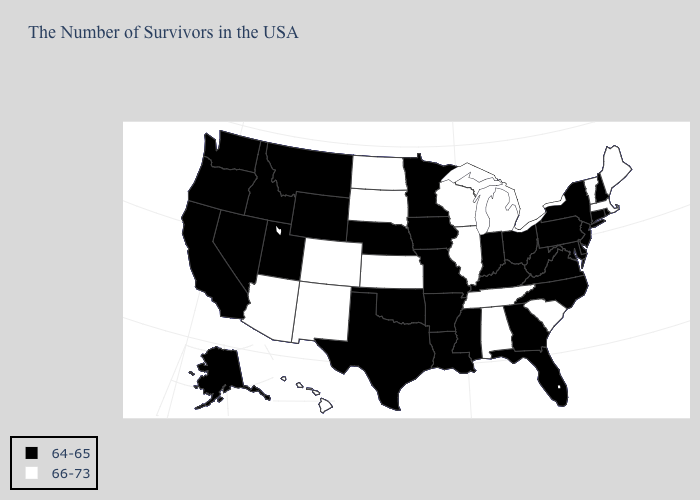Which states hav the highest value in the South?
Answer briefly. South Carolina, Alabama, Tennessee. Does the first symbol in the legend represent the smallest category?
Quick response, please. Yes. What is the value of Kansas?
Keep it brief. 66-73. Does California have a lower value than Connecticut?
Write a very short answer. No. Does Idaho have a higher value than Iowa?
Write a very short answer. No. Name the states that have a value in the range 66-73?
Answer briefly. Maine, Massachusetts, Vermont, South Carolina, Michigan, Alabama, Tennessee, Wisconsin, Illinois, Kansas, South Dakota, North Dakota, Colorado, New Mexico, Arizona, Hawaii. Name the states that have a value in the range 66-73?
Answer briefly. Maine, Massachusetts, Vermont, South Carolina, Michigan, Alabama, Tennessee, Wisconsin, Illinois, Kansas, South Dakota, North Dakota, Colorado, New Mexico, Arizona, Hawaii. Name the states that have a value in the range 64-65?
Answer briefly. Rhode Island, New Hampshire, Connecticut, New York, New Jersey, Delaware, Maryland, Pennsylvania, Virginia, North Carolina, West Virginia, Ohio, Florida, Georgia, Kentucky, Indiana, Mississippi, Louisiana, Missouri, Arkansas, Minnesota, Iowa, Nebraska, Oklahoma, Texas, Wyoming, Utah, Montana, Idaho, Nevada, California, Washington, Oregon, Alaska. Which states have the lowest value in the USA?
Write a very short answer. Rhode Island, New Hampshire, Connecticut, New York, New Jersey, Delaware, Maryland, Pennsylvania, Virginia, North Carolina, West Virginia, Ohio, Florida, Georgia, Kentucky, Indiana, Mississippi, Louisiana, Missouri, Arkansas, Minnesota, Iowa, Nebraska, Oklahoma, Texas, Wyoming, Utah, Montana, Idaho, Nevada, California, Washington, Oregon, Alaska. Does Vermont have the highest value in the Northeast?
Keep it brief. Yes. What is the value of West Virginia?
Be succinct. 64-65. Among the states that border Oklahoma , does Colorado have the lowest value?
Short answer required. No. Name the states that have a value in the range 66-73?
Concise answer only. Maine, Massachusetts, Vermont, South Carolina, Michigan, Alabama, Tennessee, Wisconsin, Illinois, Kansas, South Dakota, North Dakota, Colorado, New Mexico, Arizona, Hawaii. Name the states that have a value in the range 64-65?
Give a very brief answer. Rhode Island, New Hampshire, Connecticut, New York, New Jersey, Delaware, Maryland, Pennsylvania, Virginia, North Carolina, West Virginia, Ohio, Florida, Georgia, Kentucky, Indiana, Mississippi, Louisiana, Missouri, Arkansas, Minnesota, Iowa, Nebraska, Oklahoma, Texas, Wyoming, Utah, Montana, Idaho, Nevada, California, Washington, Oregon, Alaska. 